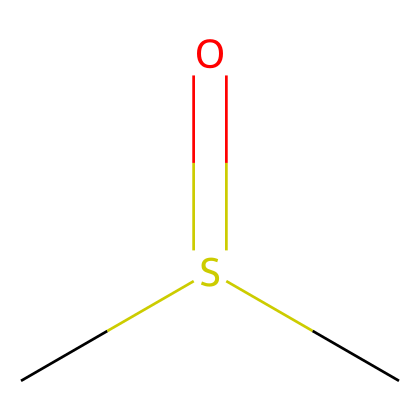How many carbon atoms are in dimethyl sulfoxide? The SMILES representation shows two 'C' atoms, indicating that there are two carbon atoms in the molecule.
Answer: 2 What is the functional group present in dimethyl sulfoxide? The 'S(=O)' part in the SMILES signifies that there is a sulfur atom double bonded to an oxygen atom, which represents a sulfoxide functional group.
Answer: sulfoxide What is the oxidation state of sulfur in dimethyl sulfoxide? Analyzing the bonding, we observe that sulfur is bonded to two carbon atoms (which are less electronegative) and has a double bond with oxygen (more electronegative). This leads to the conclusion that sulfur has an oxidation state of +2 in this compound.
Answer: +2 How many oxygen atoms are present in dimethyl sulfoxide? The SMILES notation includes one 'O' connected to the sulfur atom indicating there is one oxygen atom in the structure.
Answer: 1 Is dimethyl sulfoxide a polar molecule? The presence of a highly electronegative oxygen atom and the dipole created by the sulfur's bonding leads to the conclusion that this molecule possesses a net dipole moment, making it polar.
Answer: yes What is the total number of hydrogen atoms in dimethyl sulfoxide? The two methyl groups (each denoted as 'C') contribute a total of six hydrogen atoms, corresponding to the formula CH3-S(=O)-CH3, meaning there are six hydrogen atoms in total.
Answer: 6 Which type of bonding predominates in dimethyl sulfoxide? The molecule contains covalent bonds between the carbon, sulfur, and oxygen atoms, as these atoms share electrons to form stable structures.
Answer: covalent 